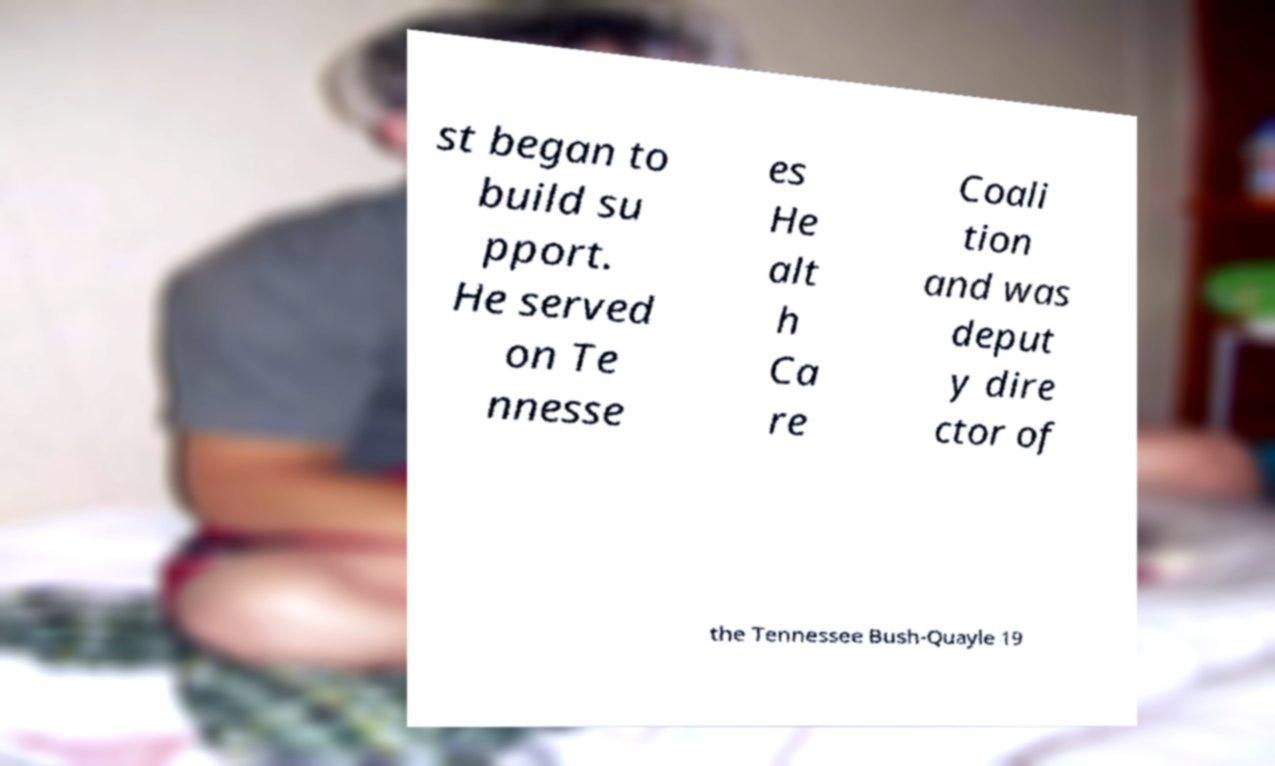Can you read and provide the text displayed in the image?This photo seems to have some interesting text. Can you extract and type it out for me? st began to build su pport. He served on Te nnesse es He alt h Ca re Coali tion and was deput y dire ctor of the Tennessee Bush-Quayle 19 